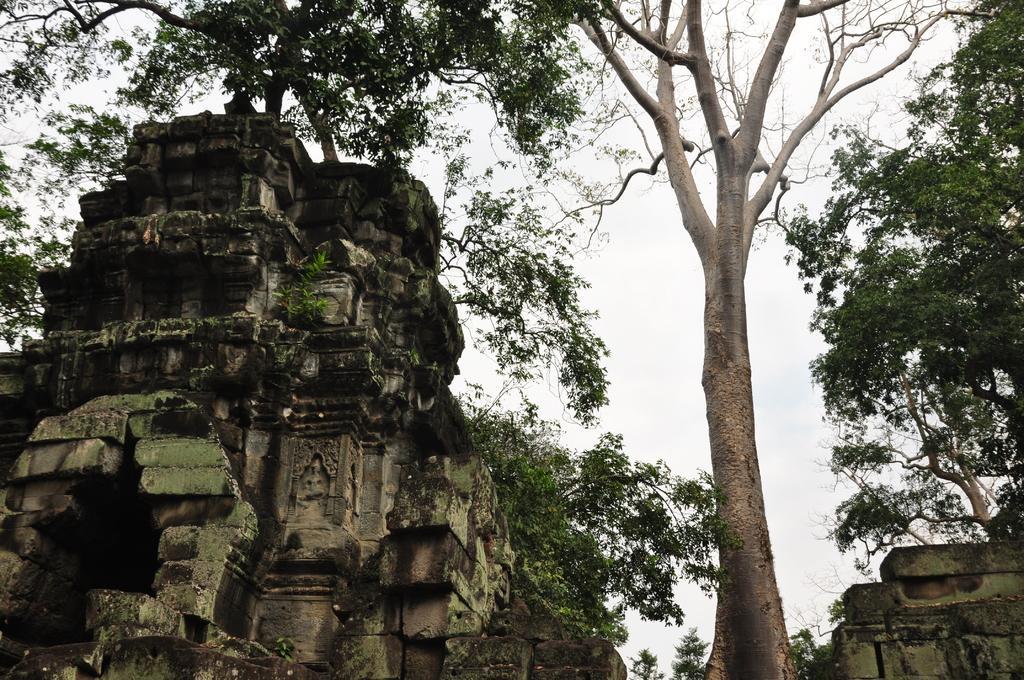How would you summarize this image in a sentence or two? In this image we can see a monument, some plants, trees and the sky which looks cloudy. 